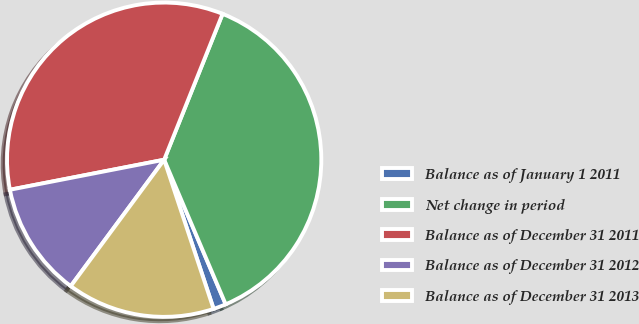<chart> <loc_0><loc_0><loc_500><loc_500><pie_chart><fcel>Balance as of January 1 2011<fcel>Net change in period<fcel>Balance as of December 31 2011<fcel>Balance as of December 31 2012<fcel>Balance as of December 31 2013<nl><fcel>1.31%<fcel>37.53%<fcel>34.12%<fcel>11.81%<fcel>15.22%<nl></chart> 